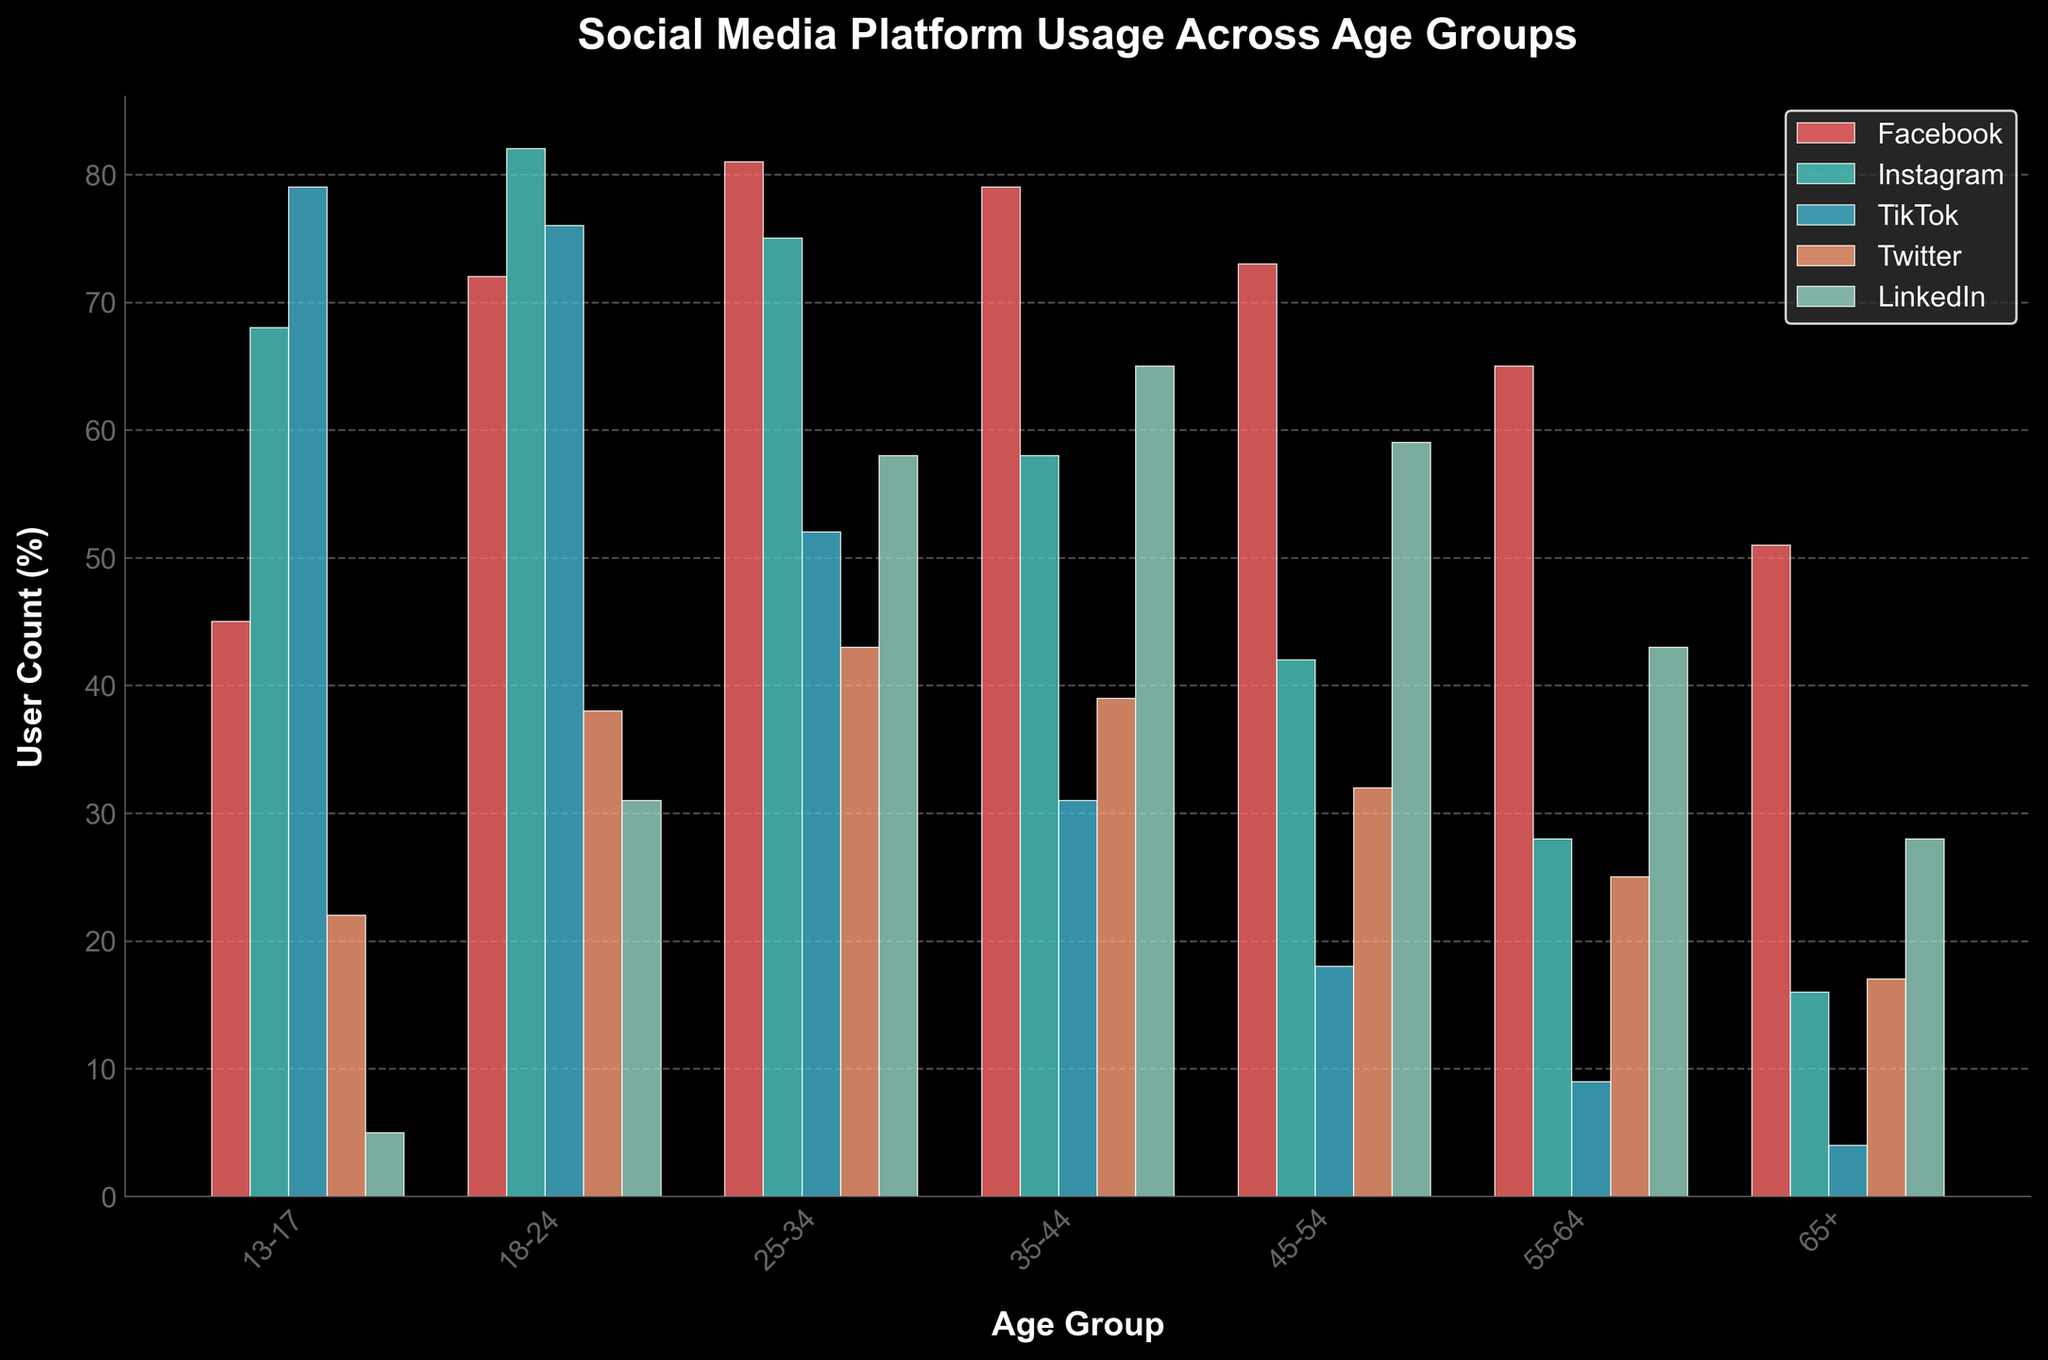Which age group shows the highest user count for TikTok? Look at the bar heights for TikTok across different age groups. The highest bar represents the age group with the highest user count. In this case, it's the 13-17 age group.
Answer: 13-17 Which social media platform is least used by the 65+ age group? Compare the bar heights for different social media platforms within the 65+ age group. The smallest bar represents the least used platform, which is TikTok.
Answer: TikTok Between the 25-34 and 35-44 age groups, which one has more Twitter users? Compare the bar heights for Twitter between the 25-34 and 35-44 age groups. The higher bar indicates more users. The 25-34 age group has more Twitter users.
Answer: 25-34 What's the combined user count percentage of Instagram for the 13-17 and 18-24 age groups? Check the bar heights for Instagram in the 13-17 and 18-24 age groups and sum them up. The heights are 68 and 82, so the combined user count is 68 + 82 = 150.
Answer: 150 Which social media platform shows the most consistent usage across all age groups? Look for a platform where the bar heights are relatively even across all age groups. Facebook has the most consistent usage compared to other platforms.
Answer: Facebook What's the average user count for LinkedIn across all age groups? Sum the LinkedIn user counts for all age groups (5 + 31 + 58 + 65 + 59 + 43 + 28) and divide by the number of age groups (7). The total is 289, so the average is 289 / 7 ≈ 41.29.
Answer: 41.29 How does usage of Instagram among 35-44 age group compare to Twitter usage in the same group? Compare the bar heights for Instagram and Twitter within the 35-44 age group. Instagram usage (58) is significantly higher than Twitter usage (39).
Answer: Instagram is higher What is the difference between the user count of Facebook for the 55-64 age group and TikTok for the 45-54 age group? Look at the bar heights for Facebook and TikTok in their respective age groups. Facebook (65) and TikTok (18), then calculate the difference: 65 - 18 = 47.
Answer: 47 What color represents the LinkedIn bars in the chart? Observe the colors corresponding to each platform in the legend. LinkedIn bars are represented by a mint green color.
Answer: Mint green 